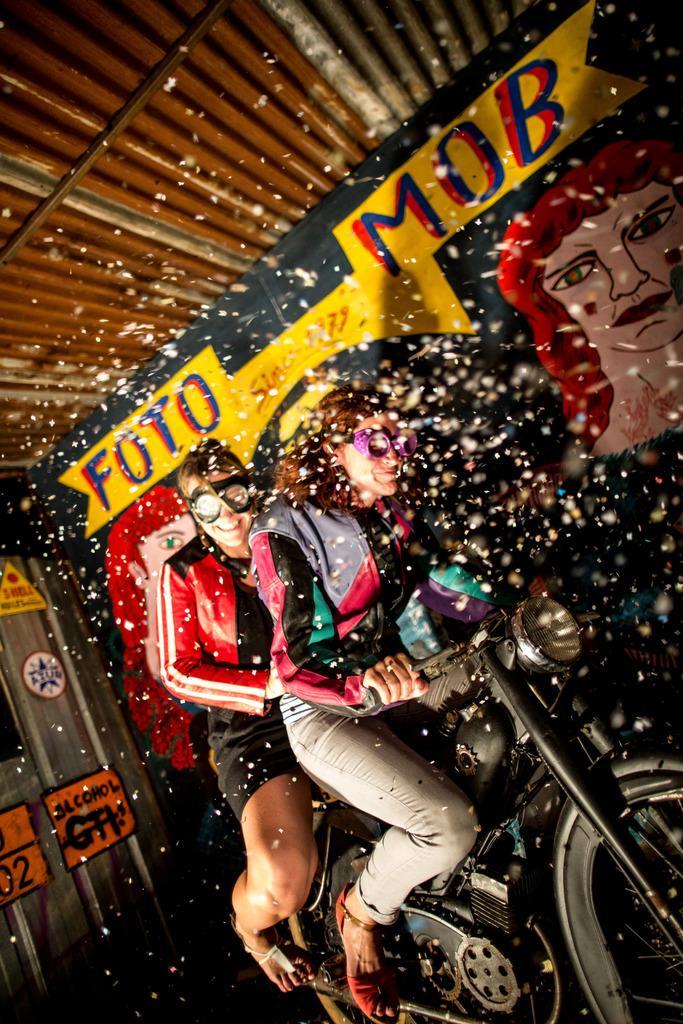Please provide a concise description of this image. In this picture I can see there are two people sitting on the motorcycle and in the backdrop I can see there is a banner. 